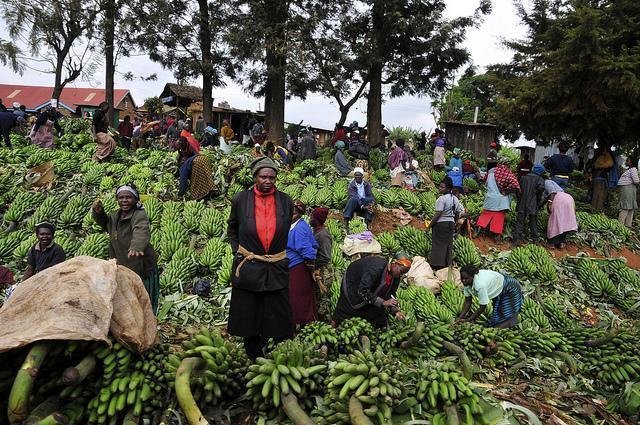What food group do these plantains belong to?
From the following four choices, select the correct answer to address the question.
Options: Vegetables, grains, fruits, seeds. Fruits. 